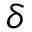Convert formula to latex. <formula><loc_0><loc_0><loc_500><loc_500>\delta</formula> 